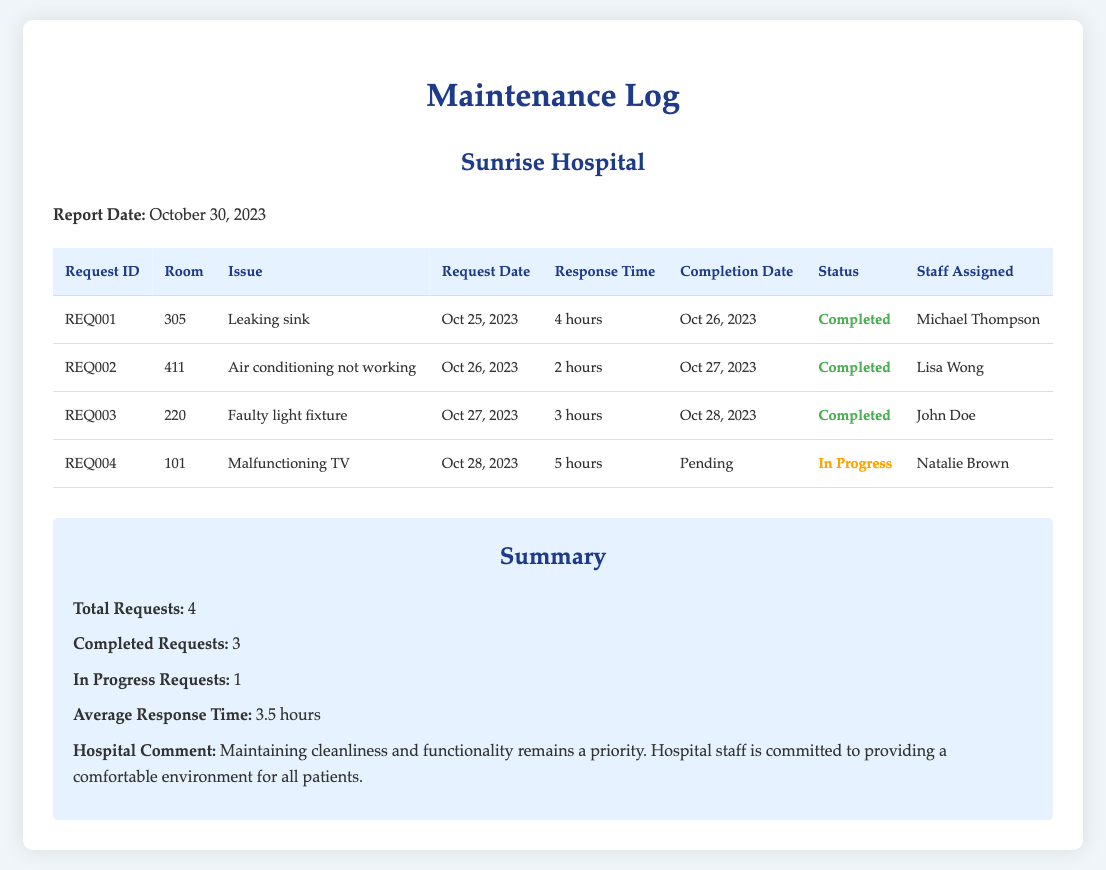What is the total number of maintenance requests? The total number of maintenance requests is explicitly stated in the summary section of the log.
Answer: 4 What is the request ID of the maintenance issue for the leaking sink? The request ID for the leaking sink can be found in the table under the 'Request ID' column.
Answer: REQ001 Who is the staff member assigned to the malfunctioning TV issue? The staff member's name assigned to the malfunctioning TV is listed in the table under the 'Staff Assigned' column.
Answer: Natalie Brown What is the response time for the air conditioning issue? The response time for the air conditioning issue can be retrieved from the table in the corresponding row.
Answer: 2 hours How many requests are still in progress? The number of in-progress requests is indicated in the summary section of the document.
Answer: 1 What was the completion date for the faulty light fixture? The completion date for the faulty light fixture is shown in the table under the 'Completion Date' column.
Answer: Oct 28, 2023 What is the average response time for the requests? The average response time is given in the summary section of the document as one of the statistics.
Answer: 3.5 hours What is the status of request REQ004? The status of request REQ004 is indicated in the table under the 'Status' column.
Answer: In Progress What is the issue reported in room 411? The issue reported in room 411 can be found in the table under the 'Issue' column.
Answer: Air conditioning not working 